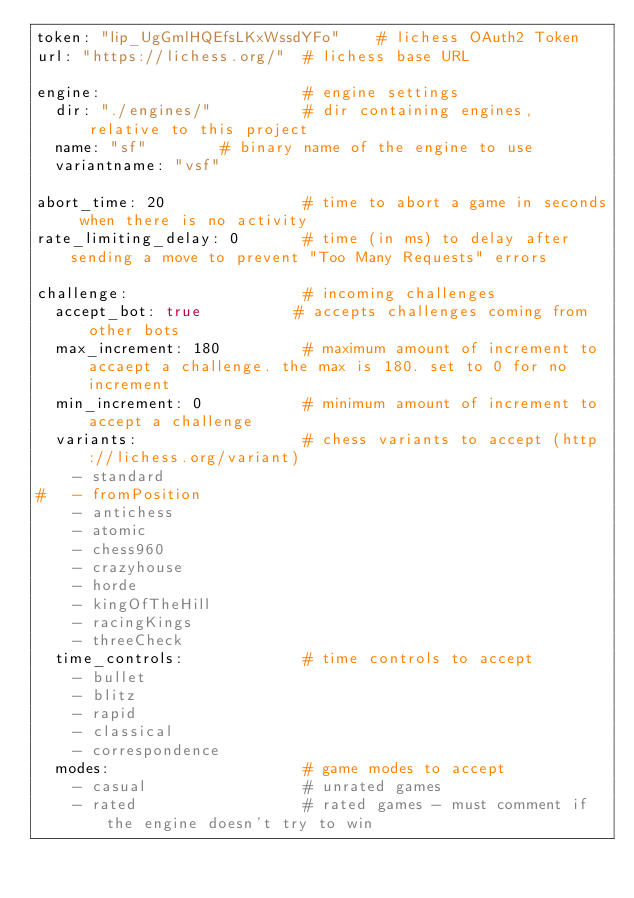Convert code to text. <code><loc_0><loc_0><loc_500><loc_500><_YAML_>token: "lip_UgGmlHQEfsLKxWssdYFo"    # lichess OAuth2 Token
url: "https://lichess.org/"  # lichess base URL

engine:                      # engine settings
  dir: "./engines/"          # dir containing engines, relative to this project
  name: "sf"        # binary name of the engine to use
  variantname: "vsf"

abort_time: 20               # time to abort a game in seconds when there is no activity
rate_limiting_delay: 0       # time (in ms) to delay after sending a move to prevent "Too Many Requests" errors

challenge:                   # incoming challenges
  accept_bot: true          # accepts challenges coming from other bots
  max_increment: 180         # maximum amount of increment to accaept a challenge. the max is 180. set to 0 for no increment
  min_increment: 0           # minimum amount of increment to accept a challenge
  variants:                  # chess variants to accept (http://lichess.org/variant)
    - standard
#   - fromPosition
    - antichess
    - atomic
    - chess960
    - crazyhouse
    - horde
    - kingOfTheHill
    - racingKings
    - threeCheck
  time_controls:             # time controls to accept
    - bullet
    - blitz
    - rapid
    - classical
    - correspondence
  modes:                     # game modes to accept
    - casual                 # unrated games
    - rated                  # rated games - must comment if the engine doesn't try to win
</code> 